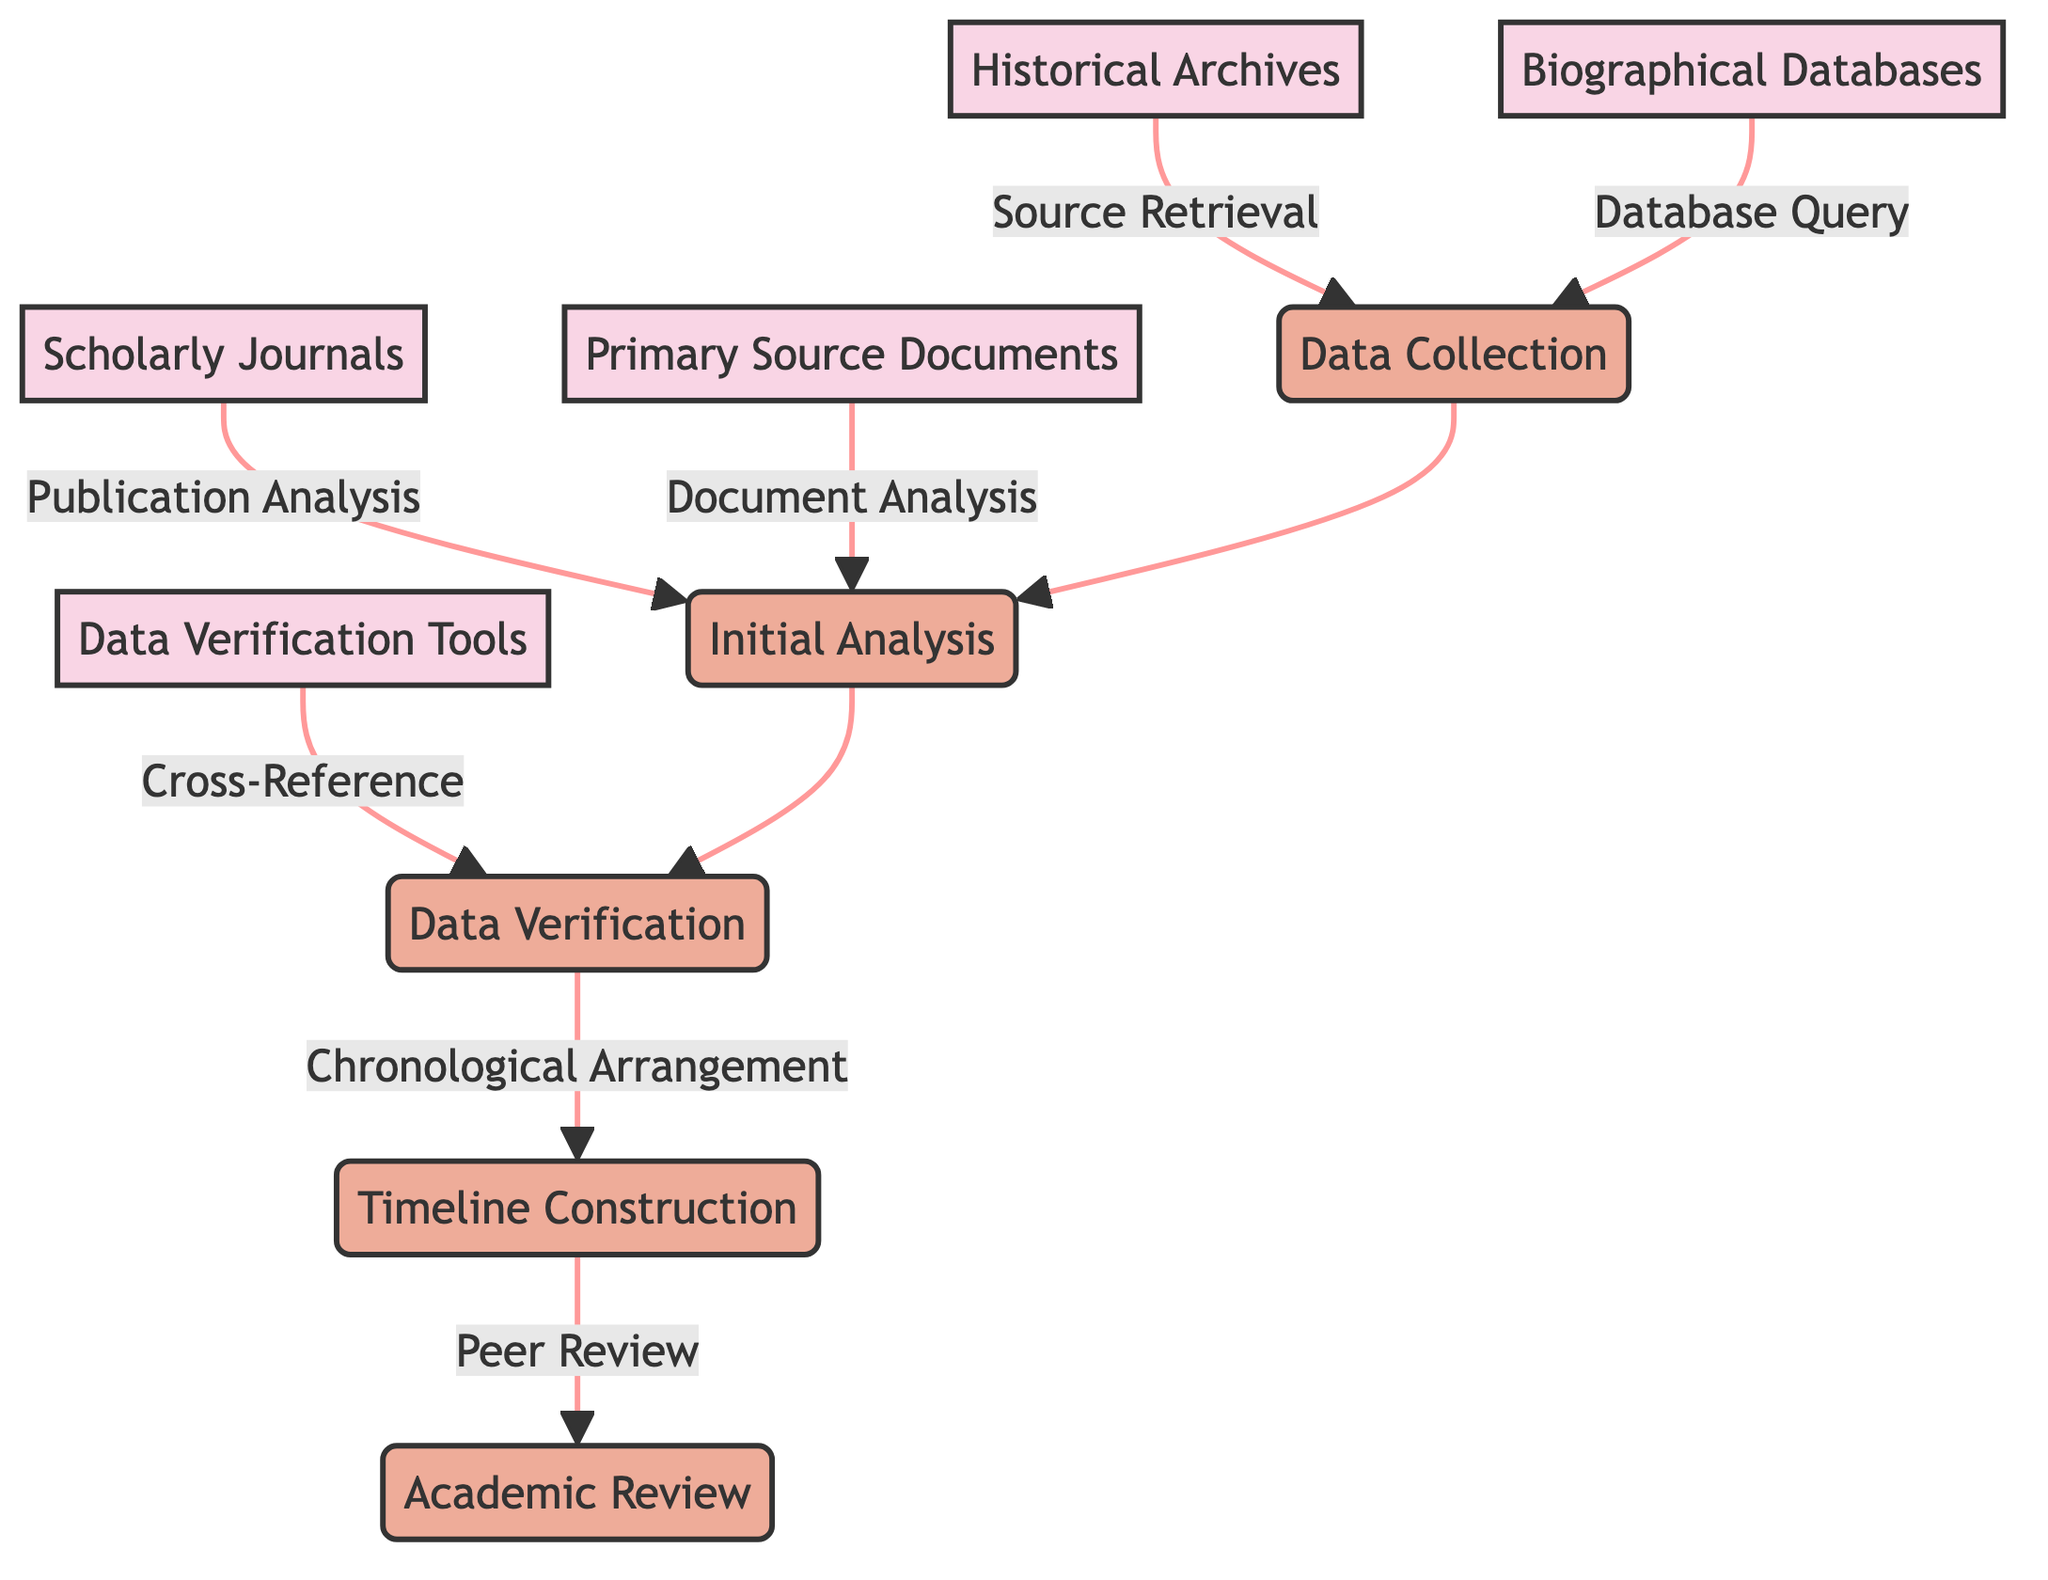What's the total number of entities in the diagram? The diagram includes five entities: Historical Archives, Scholarly Journals, Biographical Databases, Primary Source Documents, and Data Verification Tools. Counting these gives a total of five entities.
Answer: 5 What process is directly after Data Collection? In the flow of processes shown in the diagram, Initial Analysis follows Data Collection. This can be confirmed by observing the arrow connecting the two.
Answer: Initial Analysis Which entity provides source retrieval to Data Collection? Historical Archives is indicated in the diagram as the source that directly sends data to Data Collection through the specified flow of 'Source Retrieval'.
Answer: Historical Archives What is the last process in the diagram? The last process indicated in the flow of the diagram is Academic Review, as it receives output from the previous process, Timeline Construction.
Answer: Academic Review How many data flows are present in the diagram? By reviewing the connections shown in the diagram, there are a total of seven distinct data flows listed, linking the various entities and processes.
Answer: 7 Which process comes after Data Verification? The diagram directly shows that Timeline Construction occurs after the Data Verification process. The flow lines confirm this sequence.
Answer: Timeline Construction What is the relationship between Data Verification Tools and Data Verification? The Data Verification Tools provide a 'Cross-Reference' flow to the Data Verification process, indicating how data verification is enhanced by these tools.
Answer: Cross-Reference Which entities are linked to Initial Analysis? The entities linked to Initial Analysis are Scholarly Journals and Primary Source Documents. The diagram shows both connections leading into this process.
Answer: Scholarly Journals, Primary Source Documents What connects Timeline Construction to Academic Review? The connection from Timeline Construction to Academic Review is labeled 'Peer Review', indicating that timelines are shared for validation within scholarly communities.
Answer: Peer Review 